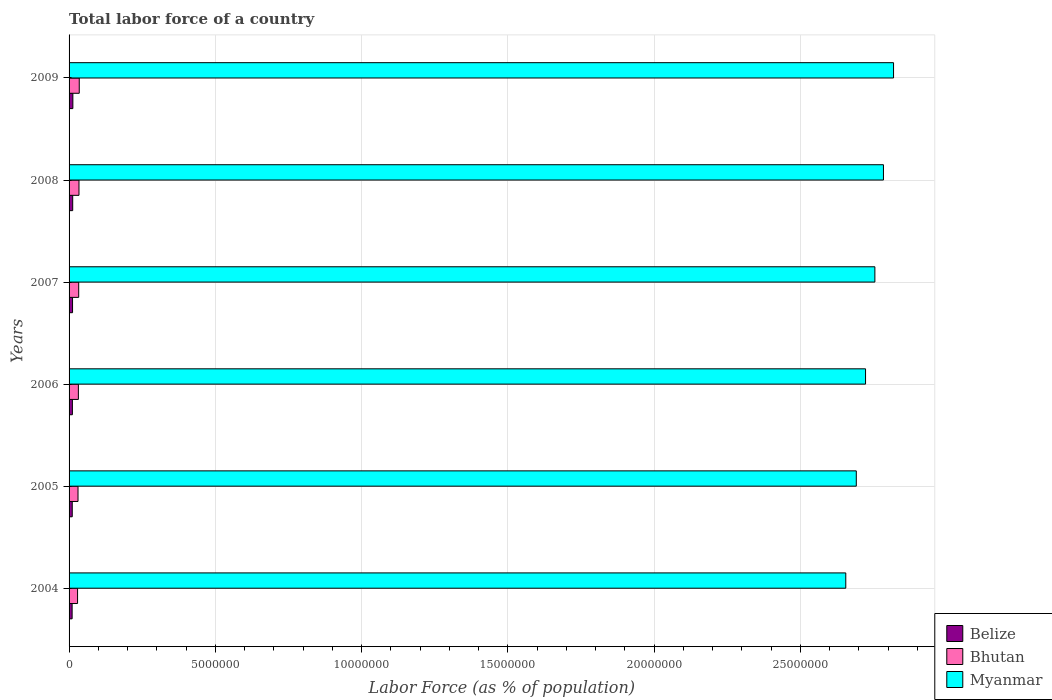How many different coloured bars are there?
Make the answer very short. 3. How many groups of bars are there?
Your answer should be very brief. 6. Are the number of bars on each tick of the Y-axis equal?
Offer a very short reply. Yes. How many bars are there on the 2nd tick from the top?
Provide a short and direct response. 3. What is the label of the 5th group of bars from the top?
Give a very brief answer. 2005. In how many cases, is the number of bars for a given year not equal to the number of legend labels?
Provide a succinct answer. 0. What is the percentage of labor force in Bhutan in 2009?
Offer a very short reply. 3.48e+05. Across all years, what is the maximum percentage of labor force in Belize?
Ensure brevity in your answer.  1.30e+05. Across all years, what is the minimum percentage of labor force in Belize?
Give a very brief answer. 1.04e+05. What is the total percentage of labor force in Bhutan in the graph?
Offer a terse response. 1.93e+06. What is the difference between the percentage of labor force in Belize in 2006 and that in 2008?
Your response must be concise. -1.07e+04. What is the difference between the percentage of labor force in Belize in 2006 and the percentage of labor force in Bhutan in 2008?
Offer a terse response. -2.26e+05. What is the average percentage of labor force in Bhutan per year?
Your answer should be very brief. 3.22e+05. In the year 2007, what is the difference between the percentage of labor force in Belize and percentage of labor force in Bhutan?
Ensure brevity in your answer.  -2.10e+05. What is the ratio of the percentage of labor force in Bhutan in 2007 to that in 2008?
Offer a very short reply. 0.97. What is the difference between the highest and the second highest percentage of labor force in Bhutan?
Your answer should be very brief. 9045. What is the difference between the highest and the lowest percentage of labor force in Bhutan?
Your response must be concise. 5.77e+04. Is the sum of the percentage of labor force in Belize in 2005 and 2008 greater than the maximum percentage of labor force in Bhutan across all years?
Offer a very short reply. No. What does the 3rd bar from the top in 2007 represents?
Provide a succinct answer. Belize. What does the 3rd bar from the bottom in 2004 represents?
Your response must be concise. Myanmar. Is it the case that in every year, the sum of the percentage of labor force in Bhutan and percentage of labor force in Myanmar is greater than the percentage of labor force in Belize?
Provide a succinct answer. Yes. How many bars are there?
Offer a terse response. 18. Are all the bars in the graph horizontal?
Give a very brief answer. Yes. Does the graph contain any zero values?
Ensure brevity in your answer.  No. How are the legend labels stacked?
Make the answer very short. Vertical. What is the title of the graph?
Offer a very short reply. Total labor force of a country. Does "St. Lucia" appear as one of the legend labels in the graph?
Your response must be concise. No. What is the label or title of the X-axis?
Your answer should be very brief. Labor Force (as % of population). What is the Labor Force (as % of population) of Belize in 2004?
Keep it short and to the point. 1.04e+05. What is the Labor Force (as % of population) in Bhutan in 2004?
Offer a very short reply. 2.90e+05. What is the Labor Force (as % of population) in Myanmar in 2004?
Offer a terse response. 2.65e+07. What is the Labor Force (as % of population) of Belize in 2005?
Provide a succinct answer. 1.08e+05. What is the Labor Force (as % of population) of Bhutan in 2005?
Your answer should be compact. 3.06e+05. What is the Labor Force (as % of population) of Myanmar in 2005?
Provide a short and direct response. 2.69e+07. What is the Labor Force (as % of population) of Belize in 2006?
Provide a succinct answer. 1.13e+05. What is the Labor Force (as % of population) in Bhutan in 2006?
Make the answer very short. 3.18e+05. What is the Labor Force (as % of population) in Myanmar in 2006?
Ensure brevity in your answer.  2.72e+07. What is the Labor Force (as % of population) in Belize in 2007?
Provide a short and direct response. 1.19e+05. What is the Labor Force (as % of population) in Bhutan in 2007?
Offer a terse response. 3.29e+05. What is the Labor Force (as % of population) of Myanmar in 2007?
Your response must be concise. 2.75e+07. What is the Labor Force (as % of population) in Belize in 2008?
Provide a succinct answer. 1.24e+05. What is the Labor Force (as % of population) of Bhutan in 2008?
Your answer should be very brief. 3.39e+05. What is the Labor Force (as % of population) of Myanmar in 2008?
Your response must be concise. 2.78e+07. What is the Labor Force (as % of population) in Belize in 2009?
Provide a succinct answer. 1.30e+05. What is the Labor Force (as % of population) in Bhutan in 2009?
Make the answer very short. 3.48e+05. What is the Labor Force (as % of population) of Myanmar in 2009?
Offer a very short reply. 2.82e+07. Across all years, what is the maximum Labor Force (as % of population) of Belize?
Your answer should be compact. 1.30e+05. Across all years, what is the maximum Labor Force (as % of population) in Bhutan?
Provide a succinct answer. 3.48e+05. Across all years, what is the maximum Labor Force (as % of population) of Myanmar?
Offer a very short reply. 2.82e+07. Across all years, what is the minimum Labor Force (as % of population) of Belize?
Ensure brevity in your answer.  1.04e+05. Across all years, what is the minimum Labor Force (as % of population) in Bhutan?
Your response must be concise. 2.90e+05. Across all years, what is the minimum Labor Force (as % of population) in Myanmar?
Provide a succinct answer. 2.65e+07. What is the total Labor Force (as % of population) of Belize in the graph?
Ensure brevity in your answer.  6.99e+05. What is the total Labor Force (as % of population) of Bhutan in the graph?
Offer a terse response. 1.93e+06. What is the total Labor Force (as % of population) in Myanmar in the graph?
Provide a short and direct response. 1.64e+08. What is the difference between the Labor Force (as % of population) in Belize in 2004 and that in 2005?
Your answer should be compact. -4002. What is the difference between the Labor Force (as % of population) of Bhutan in 2004 and that in 2005?
Provide a succinct answer. -1.53e+04. What is the difference between the Labor Force (as % of population) in Myanmar in 2004 and that in 2005?
Ensure brevity in your answer.  -3.60e+05. What is the difference between the Labor Force (as % of population) of Belize in 2004 and that in 2006?
Offer a very short reply. -8926. What is the difference between the Labor Force (as % of population) of Bhutan in 2004 and that in 2006?
Your answer should be very brief. -2.79e+04. What is the difference between the Labor Force (as % of population) of Myanmar in 2004 and that in 2006?
Offer a terse response. -6.75e+05. What is the difference between the Labor Force (as % of population) of Belize in 2004 and that in 2007?
Provide a succinct answer. -1.43e+04. What is the difference between the Labor Force (as % of population) in Bhutan in 2004 and that in 2007?
Your response must be concise. -3.89e+04. What is the difference between the Labor Force (as % of population) in Myanmar in 2004 and that in 2007?
Your response must be concise. -9.94e+05. What is the difference between the Labor Force (as % of population) in Belize in 2004 and that in 2008?
Offer a terse response. -1.96e+04. What is the difference between the Labor Force (as % of population) in Bhutan in 2004 and that in 2008?
Provide a succinct answer. -4.87e+04. What is the difference between the Labor Force (as % of population) of Myanmar in 2004 and that in 2008?
Ensure brevity in your answer.  -1.29e+06. What is the difference between the Labor Force (as % of population) in Belize in 2004 and that in 2009?
Your answer should be compact. -2.53e+04. What is the difference between the Labor Force (as % of population) in Bhutan in 2004 and that in 2009?
Provide a succinct answer. -5.77e+04. What is the difference between the Labor Force (as % of population) of Myanmar in 2004 and that in 2009?
Offer a terse response. -1.63e+06. What is the difference between the Labor Force (as % of population) of Belize in 2005 and that in 2006?
Provide a succinct answer. -4924. What is the difference between the Labor Force (as % of population) in Bhutan in 2005 and that in 2006?
Provide a short and direct response. -1.26e+04. What is the difference between the Labor Force (as % of population) in Myanmar in 2005 and that in 2006?
Your response must be concise. -3.16e+05. What is the difference between the Labor Force (as % of population) of Belize in 2005 and that in 2007?
Offer a very short reply. -1.03e+04. What is the difference between the Labor Force (as % of population) in Bhutan in 2005 and that in 2007?
Make the answer very short. -2.35e+04. What is the difference between the Labor Force (as % of population) of Myanmar in 2005 and that in 2007?
Your answer should be compact. -6.35e+05. What is the difference between the Labor Force (as % of population) in Belize in 2005 and that in 2008?
Provide a short and direct response. -1.56e+04. What is the difference between the Labor Force (as % of population) of Bhutan in 2005 and that in 2008?
Offer a very short reply. -3.33e+04. What is the difference between the Labor Force (as % of population) of Myanmar in 2005 and that in 2008?
Your response must be concise. -9.28e+05. What is the difference between the Labor Force (as % of population) of Belize in 2005 and that in 2009?
Provide a succinct answer. -2.13e+04. What is the difference between the Labor Force (as % of population) in Bhutan in 2005 and that in 2009?
Your answer should be compact. -4.24e+04. What is the difference between the Labor Force (as % of population) of Myanmar in 2005 and that in 2009?
Your answer should be very brief. -1.27e+06. What is the difference between the Labor Force (as % of population) in Belize in 2006 and that in 2007?
Provide a short and direct response. -5334. What is the difference between the Labor Force (as % of population) in Bhutan in 2006 and that in 2007?
Your answer should be very brief. -1.09e+04. What is the difference between the Labor Force (as % of population) in Myanmar in 2006 and that in 2007?
Offer a very short reply. -3.19e+05. What is the difference between the Labor Force (as % of population) of Belize in 2006 and that in 2008?
Provide a short and direct response. -1.07e+04. What is the difference between the Labor Force (as % of population) in Bhutan in 2006 and that in 2008?
Provide a short and direct response. -2.08e+04. What is the difference between the Labor Force (as % of population) in Myanmar in 2006 and that in 2008?
Keep it short and to the point. -6.12e+05. What is the difference between the Labor Force (as % of population) of Belize in 2006 and that in 2009?
Keep it short and to the point. -1.64e+04. What is the difference between the Labor Force (as % of population) in Bhutan in 2006 and that in 2009?
Ensure brevity in your answer.  -2.98e+04. What is the difference between the Labor Force (as % of population) of Myanmar in 2006 and that in 2009?
Your answer should be very brief. -9.57e+05. What is the difference between the Labor Force (as % of population) of Belize in 2007 and that in 2008?
Offer a terse response. -5347. What is the difference between the Labor Force (as % of population) in Bhutan in 2007 and that in 2008?
Offer a very short reply. -9826. What is the difference between the Labor Force (as % of population) of Myanmar in 2007 and that in 2008?
Offer a very short reply. -2.93e+05. What is the difference between the Labor Force (as % of population) in Belize in 2007 and that in 2009?
Your response must be concise. -1.10e+04. What is the difference between the Labor Force (as % of population) of Bhutan in 2007 and that in 2009?
Your answer should be very brief. -1.89e+04. What is the difference between the Labor Force (as % of population) of Myanmar in 2007 and that in 2009?
Your answer should be compact. -6.38e+05. What is the difference between the Labor Force (as % of population) in Belize in 2008 and that in 2009?
Give a very brief answer. -5678. What is the difference between the Labor Force (as % of population) of Bhutan in 2008 and that in 2009?
Provide a short and direct response. -9045. What is the difference between the Labor Force (as % of population) of Myanmar in 2008 and that in 2009?
Keep it short and to the point. -3.45e+05. What is the difference between the Labor Force (as % of population) of Belize in 2004 and the Labor Force (as % of population) of Bhutan in 2005?
Your response must be concise. -2.01e+05. What is the difference between the Labor Force (as % of population) in Belize in 2004 and the Labor Force (as % of population) in Myanmar in 2005?
Provide a succinct answer. -2.68e+07. What is the difference between the Labor Force (as % of population) in Bhutan in 2004 and the Labor Force (as % of population) in Myanmar in 2005?
Keep it short and to the point. -2.66e+07. What is the difference between the Labor Force (as % of population) in Belize in 2004 and the Labor Force (as % of population) in Bhutan in 2006?
Your response must be concise. -2.14e+05. What is the difference between the Labor Force (as % of population) in Belize in 2004 and the Labor Force (as % of population) in Myanmar in 2006?
Provide a short and direct response. -2.71e+07. What is the difference between the Labor Force (as % of population) in Bhutan in 2004 and the Labor Force (as % of population) in Myanmar in 2006?
Give a very brief answer. -2.69e+07. What is the difference between the Labor Force (as % of population) of Belize in 2004 and the Labor Force (as % of population) of Bhutan in 2007?
Ensure brevity in your answer.  -2.25e+05. What is the difference between the Labor Force (as % of population) in Belize in 2004 and the Labor Force (as % of population) in Myanmar in 2007?
Offer a terse response. -2.74e+07. What is the difference between the Labor Force (as % of population) of Bhutan in 2004 and the Labor Force (as % of population) of Myanmar in 2007?
Make the answer very short. -2.73e+07. What is the difference between the Labor Force (as % of population) of Belize in 2004 and the Labor Force (as % of population) of Bhutan in 2008?
Provide a succinct answer. -2.34e+05. What is the difference between the Labor Force (as % of population) of Belize in 2004 and the Labor Force (as % of population) of Myanmar in 2008?
Offer a very short reply. -2.77e+07. What is the difference between the Labor Force (as % of population) of Bhutan in 2004 and the Labor Force (as % of population) of Myanmar in 2008?
Give a very brief answer. -2.75e+07. What is the difference between the Labor Force (as % of population) of Belize in 2004 and the Labor Force (as % of population) of Bhutan in 2009?
Offer a terse response. -2.44e+05. What is the difference between the Labor Force (as % of population) of Belize in 2004 and the Labor Force (as % of population) of Myanmar in 2009?
Your answer should be compact. -2.81e+07. What is the difference between the Labor Force (as % of population) of Bhutan in 2004 and the Labor Force (as % of population) of Myanmar in 2009?
Offer a very short reply. -2.79e+07. What is the difference between the Labor Force (as % of population) in Belize in 2005 and the Labor Force (as % of population) in Bhutan in 2006?
Your answer should be compact. -2.10e+05. What is the difference between the Labor Force (as % of population) of Belize in 2005 and the Labor Force (as % of population) of Myanmar in 2006?
Offer a terse response. -2.71e+07. What is the difference between the Labor Force (as % of population) in Bhutan in 2005 and the Labor Force (as % of population) in Myanmar in 2006?
Give a very brief answer. -2.69e+07. What is the difference between the Labor Force (as % of population) in Belize in 2005 and the Labor Force (as % of population) in Bhutan in 2007?
Your response must be concise. -2.21e+05. What is the difference between the Labor Force (as % of population) in Belize in 2005 and the Labor Force (as % of population) in Myanmar in 2007?
Offer a terse response. -2.74e+07. What is the difference between the Labor Force (as % of population) in Bhutan in 2005 and the Labor Force (as % of population) in Myanmar in 2007?
Your answer should be compact. -2.72e+07. What is the difference between the Labor Force (as % of population) in Belize in 2005 and the Labor Force (as % of population) in Bhutan in 2008?
Provide a short and direct response. -2.30e+05. What is the difference between the Labor Force (as % of population) of Belize in 2005 and the Labor Force (as % of population) of Myanmar in 2008?
Keep it short and to the point. -2.77e+07. What is the difference between the Labor Force (as % of population) of Bhutan in 2005 and the Labor Force (as % of population) of Myanmar in 2008?
Provide a succinct answer. -2.75e+07. What is the difference between the Labor Force (as % of population) in Belize in 2005 and the Labor Force (as % of population) in Bhutan in 2009?
Provide a short and direct response. -2.40e+05. What is the difference between the Labor Force (as % of population) in Belize in 2005 and the Labor Force (as % of population) in Myanmar in 2009?
Offer a terse response. -2.81e+07. What is the difference between the Labor Force (as % of population) of Bhutan in 2005 and the Labor Force (as % of population) of Myanmar in 2009?
Your response must be concise. -2.79e+07. What is the difference between the Labor Force (as % of population) in Belize in 2006 and the Labor Force (as % of population) in Bhutan in 2007?
Make the answer very short. -2.16e+05. What is the difference between the Labor Force (as % of population) of Belize in 2006 and the Labor Force (as % of population) of Myanmar in 2007?
Offer a terse response. -2.74e+07. What is the difference between the Labor Force (as % of population) of Bhutan in 2006 and the Labor Force (as % of population) of Myanmar in 2007?
Offer a very short reply. -2.72e+07. What is the difference between the Labor Force (as % of population) in Belize in 2006 and the Labor Force (as % of population) in Bhutan in 2008?
Your response must be concise. -2.26e+05. What is the difference between the Labor Force (as % of population) in Belize in 2006 and the Labor Force (as % of population) in Myanmar in 2008?
Make the answer very short. -2.77e+07. What is the difference between the Labor Force (as % of population) of Bhutan in 2006 and the Labor Force (as % of population) of Myanmar in 2008?
Ensure brevity in your answer.  -2.75e+07. What is the difference between the Labor Force (as % of population) of Belize in 2006 and the Labor Force (as % of population) of Bhutan in 2009?
Give a very brief answer. -2.35e+05. What is the difference between the Labor Force (as % of population) in Belize in 2006 and the Labor Force (as % of population) in Myanmar in 2009?
Ensure brevity in your answer.  -2.81e+07. What is the difference between the Labor Force (as % of population) of Bhutan in 2006 and the Labor Force (as % of population) of Myanmar in 2009?
Provide a short and direct response. -2.79e+07. What is the difference between the Labor Force (as % of population) in Belize in 2007 and the Labor Force (as % of population) in Bhutan in 2008?
Ensure brevity in your answer.  -2.20e+05. What is the difference between the Labor Force (as % of population) in Belize in 2007 and the Labor Force (as % of population) in Myanmar in 2008?
Provide a short and direct response. -2.77e+07. What is the difference between the Labor Force (as % of population) in Bhutan in 2007 and the Labor Force (as % of population) in Myanmar in 2008?
Offer a very short reply. -2.75e+07. What is the difference between the Labor Force (as % of population) of Belize in 2007 and the Labor Force (as % of population) of Bhutan in 2009?
Your answer should be very brief. -2.29e+05. What is the difference between the Labor Force (as % of population) of Belize in 2007 and the Labor Force (as % of population) of Myanmar in 2009?
Give a very brief answer. -2.81e+07. What is the difference between the Labor Force (as % of population) in Bhutan in 2007 and the Labor Force (as % of population) in Myanmar in 2009?
Ensure brevity in your answer.  -2.79e+07. What is the difference between the Labor Force (as % of population) in Belize in 2008 and the Labor Force (as % of population) in Bhutan in 2009?
Make the answer very short. -2.24e+05. What is the difference between the Labor Force (as % of population) of Belize in 2008 and the Labor Force (as % of population) of Myanmar in 2009?
Your answer should be very brief. -2.81e+07. What is the difference between the Labor Force (as % of population) in Bhutan in 2008 and the Labor Force (as % of population) in Myanmar in 2009?
Provide a short and direct response. -2.78e+07. What is the average Labor Force (as % of population) in Belize per year?
Provide a short and direct response. 1.16e+05. What is the average Labor Force (as % of population) of Bhutan per year?
Provide a short and direct response. 3.22e+05. What is the average Labor Force (as % of population) of Myanmar per year?
Give a very brief answer. 2.74e+07. In the year 2004, what is the difference between the Labor Force (as % of population) of Belize and Labor Force (as % of population) of Bhutan?
Give a very brief answer. -1.86e+05. In the year 2004, what is the difference between the Labor Force (as % of population) in Belize and Labor Force (as % of population) in Myanmar?
Your answer should be very brief. -2.64e+07. In the year 2004, what is the difference between the Labor Force (as % of population) in Bhutan and Labor Force (as % of population) in Myanmar?
Ensure brevity in your answer.  -2.63e+07. In the year 2005, what is the difference between the Labor Force (as % of population) in Belize and Labor Force (as % of population) in Bhutan?
Give a very brief answer. -1.97e+05. In the year 2005, what is the difference between the Labor Force (as % of population) in Belize and Labor Force (as % of population) in Myanmar?
Provide a succinct answer. -2.68e+07. In the year 2005, what is the difference between the Labor Force (as % of population) of Bhutan and Labor Force (as % of population) of Myanmar?
Give a very brief answer. -2.66e+07. In the year 2006, what is the difference between the Labor Force (as % of population) in Belize and Labor Force (as % of population) in Bhutan?
Ensure brevity in your answer.  -2.05e+05. In the year 2006, what is the difference between the Labor Force (as % of population) of Belize and Labor Force (as % of population) of Myanmar?
Provide a succinct answer. -2.71e+07. In the year 2006, what is the difference between the Labor Force (as % of population) of Bhutan and Labor Force (as % of population) of Myanmar?
Your answer should be compact. -2.69e+07. In the year 2007, what is the difference between the Labor Force (as % of population) of Belize and Labor Force (as % of population) of Bhutan?
Provide a short and direct response. -2.10e+05. In the year 2007, what is the difference between the Labor Force (as % of population) of Belize and Labor Force (as % of population) of Myanmar?
Your response must be concise. -2.74e+07. In the year 2007, what is the difference between the Labor Force (as % of population) of Bhutan and Labor Force (as % of population) of Myanmar?
Keep it short and to the point. -2.72e+07. In the year 2008, what is the difference between the Labor Force (as % of population) of Belize and Labor Force (as % of population) of Bhutan?
Offer a terse response. -2.15e+05. In the year 2008, what is the difference between the Labor Force (as % of population) in Belize and Labor Force (as % of population) in Myanmar?
Your response must be concise. -2.77e+07. In the year 2008, what is the difference between the Labor Force (as % of population) of Bhutan and Labor Force (as % of population) of Myanmar?
Your answer should be compact. -2.75e+07. In the year 2009, what is the difference between the Labor Force (as % of population) of Belize and Labor Force (as % of population) of Bhutan?
Give a very brief answer. -2.18e+05. In the year 2009, what is the difference between the Labor Force (as % of population) of Belize and Labor Force (as % of population) of Myanmar?
Keep it short and to the point. -2.81e+07. In the year 2009, what is the difference between the Labor Force (as % of population) in Bhutan and Labor Force (as % of population) in Myanmar?
Provide a succinct answer. -2.78e+07. What is the ratio of the Labor Force (as % of population) of Belize in 2004 to that in 2005?
Offer a terse response. 0.96. What is the ratio of the Labor Force (as % of population) of Bhutan in 2004 to that in 2005?
Offer a very short reply. 0.95. What is the ratio of the Labor Force (as % of population) in Myanmar in 2004 to that in 2005?
Provide a short and direct response. 0.99. What is the ratio of the Labor Force (as % of population) of Belize in 2004 to that in 2006?
Give a very brief answer. 0.92. What is the ratio of the Labor Force (as % of population) in Bhutan in 2004 to that in 2006?
Provide a short and direct response. 0.91. What is the ratio of the Labor Force (as % of population) of Myanmar in 2004 to that in 2006?
Your answer should be very brief. 0.98. What is the ratio of the Labor Force (as % of population) of Belize in 2004 to that in 2007?
Provide a short and direct response. 0.88. What is the ratio of the Labor Force (as % of population) in Bhutan in 2004 to that in 2007?
Your response must be concise. 0.88. What is the ratio of the Labor Force (as % of population) in Myanmar in 2004 to that in 2007?
Your answer should be very brief. 0.96. What is the ratio of the Labor Force (as % of population) of Belize in 2004 to that in 2008?
Offer a terse response. 0.84. What is the ratio of the Labor Force (as % of population) of Bhutan in 2004 to that in 2008?
Your answer should be very brief. 0.86. What is the ratio of the Labor Force (as % of population) in Myanmar in 2004 to that in 2008?
Ensure brevity in your answer.  0.95. What is the ratio of the Labor Force (as % of population) in Belize in 2004 to that in 2009?
Keep it short and to the point. 0.81. What is the ratio of the Labor Force (as % of population) in Bhutan in 2004 to that in 2009?
Your answer should be compact. 0.83. What is the ratio of the Labor Force (as % of population) of Myanmar in 2004 to that in 2009?
Ensure brevity in your answer.  0.94. What is the ratio of the Labor Force (as % of population) in Belize in 2005 to that in 2006?
Make the answer very short. 0.96. What is the ratio of the Labor Force (as % of population) of Bhutan in 2005 to that in 2006?
Provide a short and direct response. 0.96. What is the ratio of the Labor Force (as % of population) of Myanmar in 2005 to that in 2006?
Offer a terse response. 0.99. What is the ratio of the Labor Force (as % of population) in Belize in 2005 to that in 2007?
Your answer should be very brief. 0.91. What is the ratio of the Labor Force (as % of population) in Bhutan in 2005 to that in 2007?
Give a very brief answer. 0.93. What is the ratio of the Labor Force (as % of population) in Belize in 2005 to that in 2008?
Make the answer very short. 0.87. What is the ratio of the Labor Force (as % of population) of Bhutan in 2005 to that in 2008?
Your answer should be compact. 0.9. What is the ratio of the Labor Force (as % of population) of Myanmar in 2005 to that in 2008?
Your answer should be very brief. 0.97. What is the ratio of the Labor Force (as % of population) of Belize in 2005 to that in 2009?
Provide a short and direct response. 0.84. What is the ratio of the Labor Force (as % of population) of Bhutan in 2005 to that in 2009?
Your response must be concise. 0.88. What is the ratio of the Labor Force (as % of population) in Myanmar in 2005 to that in 2009?
Ensure brevity in your answer.  0.95. What is the ratio of the Labor Force (as % of population) of Belize in 2006 to that in 2007?
Your response must be concise. 0.95. What is the ratio of the Labor Force (as % of population) of Bhutan in 2006 to that in 2007?
Keep it short and to the point. 0.97. What is the ratio of the Labor Force (as % of population) of Myanmar in 2006 to that in 2007?
Your response must be concise. 0.99. What is the ratio of the Labor Force (as % of population) of Belize in 2006 to that in 2008?
Provide a short and direct response. 0.91. What is the ratio of the Labor Force (as % of population) of Bhutan in 2006 to that in 2008?
Your response must be concise. 0.94. What is the ratio of the Labor Force (as % of population) of Belize in 2006 to that in 2009?
Offer a terse response. 0.87. What is the ratio of the Labor Force (as % of population) of Bhutan in 2006 to that in 2009?
Your answer should be very brief. 0.91. What is the ratio of the Labor Force (as % of population) of Belize in 2007 to that in 2008?
Offer a very short reply. 0.96. What is the ratio of the Labor Force (as % of population) in Bhutan in 2007 to that in 2008?
Provide a succinct answer. 0.97. What is the ratio of the Labor Force (as % of population) of Belize in 2007 to that in 2009?
Your response must be concise. 0.92. What is the ratio of the Labor Force (as % of population) in Bhutan in 2007 to that in 2009?
Your response must be concise. 0.95. What is the ratio of the Labor Force (as % of population) of Myanmar in 2007 to that in 2009?
Your answer should be very brief. 0.98. What is the ratio of the Labor Force (as % of population) of Belize in 2008 to that in 2009?
Your answer should be compact. 0.96. What is the ratio of the Labor Force (as % of population) of Bhutan in 2008 to that in 2009?
Offer a very short reply. 0.97. What is the ratio of the Labor Force (as % of population) in Myanmar in 2008 to that in 2009?
Your answer should be very brief. 0.99. What is the difference between the highest and the second highest Labor Force (as % of population) of Belize?
Your answer should be compact. 5678. What is the difference between the highest and the second highest Labor Force (as % of population) of Bhutan?
Your answer should be very brief. 9045. What is the difference between the highest and the second highest Labor Force (as % of population) in Myanmar?
Make the answer very short. 3.45e+05. What is the difference between the highest and the lowest Labor Force (as % of population) in Belize?
Keep it short and to the point. 2.53e+04. What is the difference between the highest and the lowest Labor Force (as % of population) in Bhutan?
Offer a very short reply. 5.77e+04. What is the difference between the highest and the lowest Labor Force (as % of population) in Myanmar?
Give a very brief answer. 1.63e+06. 